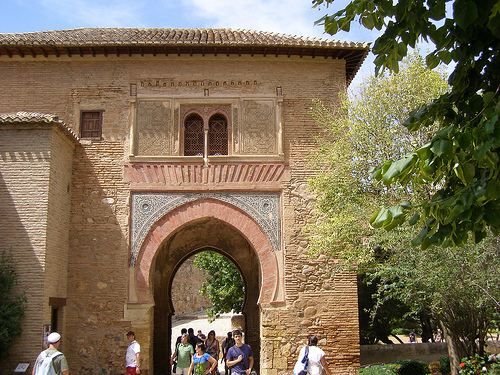<image>
Can you confirm if the woman is under the arch? Yes. The woman is positioned underneath the arch, with the arch above it in the vertical space. Is the tiles behind the tree? Yes. From this viewpoint, the tiles is positioned behind the tree, with the tree partially or fully occluding the tiles. 